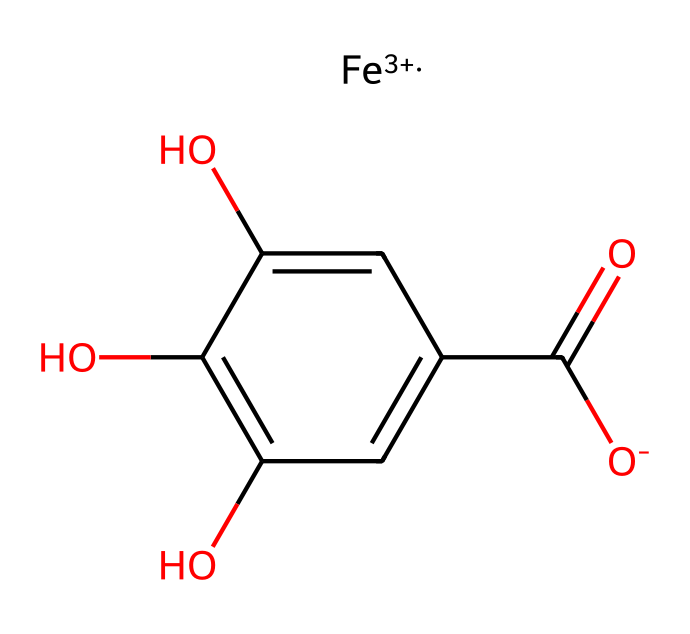What is the oxidation state of iron in this complex? The notation [Fe+3] indicates that iron has an oxidation state of +3. The "+3" signifies the charge on the iron ion.
Answer: +3 How many hydroxyl groups are present in the chemical structure? Analyzing the structure, there are three hydroxyl groups (–OH) attached to the aromatic ring, which can be counted from the fragments of the structure.
Answer: 3 What is the role of tannin in this complex? Tannin acts as a ligand in coordination chemistry, meaning it binds to the iron ion to form a coordination complex, specifically contributing its phenolic groups to stabilize the metal center.
Answer: ligand What type of complex is formed between iron and tannins? The complex is a coordination compound since it involves the coordination of a metal (iron) with ligands (tannins) through coordinate covalent bonds.
Answer: coordination compound Which functional group primarily contributes to the acidity of this compound? The carboxylic acid group (–COOH) present in the structure is responsible for acidity, as it can donate protons (H+) in solution.
Answer: carboxylic acid What is the coordination environment around the iron center? The iron center is coordinated by the hydroxyl and carboxyl groups from the tannin molecule, forming a three-dimensional structure that stabilizes the metal in solution.
Answer: hydroxyl and carboxyl groups How many carbon atoms are in the tannin structure? The structure contains a total of six carbon atoms, which can be identified by counting the carbons in the chemical skeleton of the aromatic ring and the carboxylic acid.
Answer: 6 